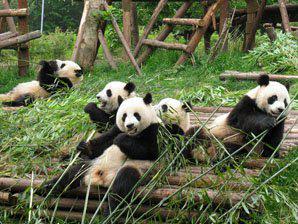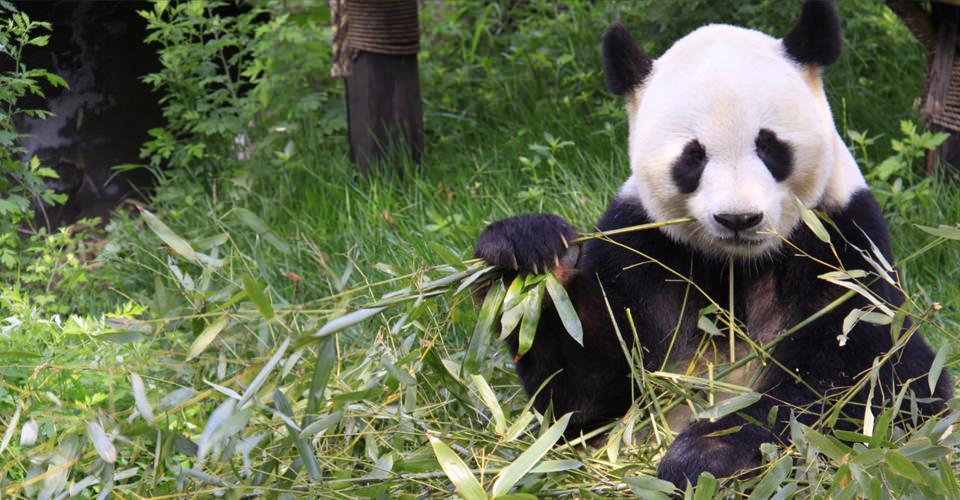The first image is the image on the left, the second image is the image on the right. Assess this claim about the two images: "An image shows exactly one panda, which is sitting and nibbling on a leafy stalk.". Correct or not? Answer yes or no. Yes. The first image is the image on the left, the second image is the image on the right. For the images displayed, is the sentence "There are at least six pandas." factually correct? Answer yes or no. Yes. 